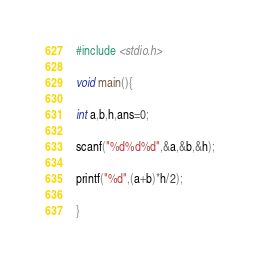Convert code to text. <code><loc_0><loc_0><loc_500><loc_500><_C_>#include <stdio.h>

void main(){

int a,b,h,ans=0;

scanf("%d%d%d",&a,&b,&h);

printf("%d",(a+b)*h/2);

}</code> 